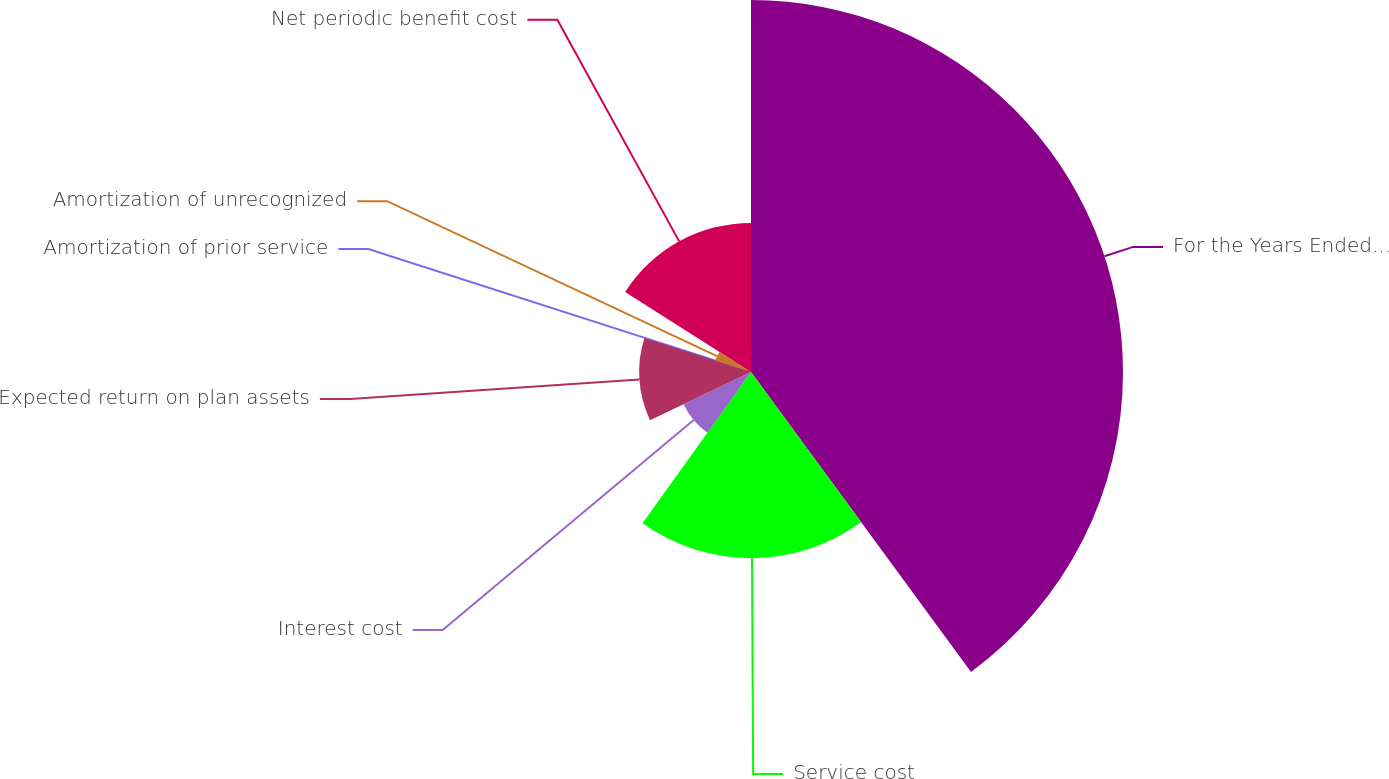<chart> <loc_0><loc_0><loc_500><loc_500><pie_chart><fcel>For the Years Ended December<fcel>Service cost<fcel>Interest cost<fcel>Expected return on plan assets<fcel>Amortization of prior service<fcel>Amortization of unrecognized<fcel>Net periodic benefit cost<nl><fcel>39.93%<fcel>19.98%<fcel>8.02%<fcel>12.01%<fcel>0.04%<fcel>4.03%<fcel>16.0%<nl></chart> 